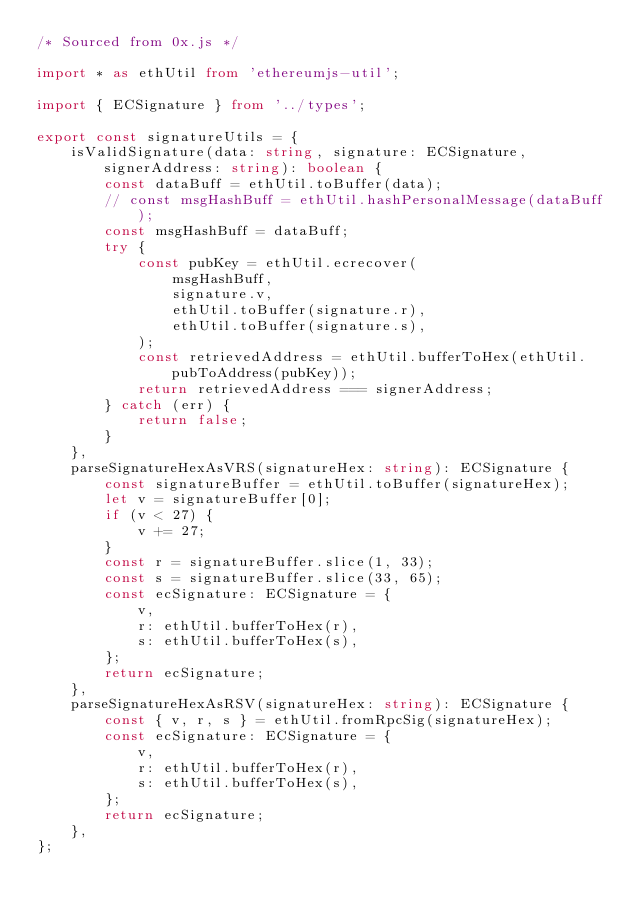<code> <loc_0><loc_0><loc_500><loc_500><_TypeScript_>/* Sourced from 0x.js */

import * as ethUtil from 'ethereumjs-util';

import { ECSignature } from '../types';

export const signatureUtils = {
    isValidSignature(data: string, signature: ECSignature, signerAddress: string): boolean {
        const dataBuff = ethUtil.toBuffer(data);
        // const msgHashBuff = ethUtil.hashPersonalMessage(dataBuff);
        const msgHashBuff = dataBuff;
        try {
            const pubKey = ethUtil.ecrecover(
                msgHashBuff,
                signature.v,
                ethUtil.toBuffer(signature.r),
                ethUtil.toBuffer(signature.s),
            );
            const retrievedAddress = ethUtil.bufferToHex(ethUtil.pubToAddress(pubKey));
            return retrievedAddress === signerAddress;
        } catch (err) {
            return false;
        }
    },
    parseSignatureHexAsVRS(signatureHex: string): ECSignature {
        const signatureBuffer = ethUtil.toBuffer(signatureHex);
        let v = signatureBuffer[0];
        if (v < 27) {
            v += 27;
        }
        const r = signatureBuffer.slice(1, 33);
        const s = signatureBuffer.slice(33, 65);
        const ecSignature: ECSignature = {
            v,
            r: ethUtil.bufferToHex(r),
            s: ethUtil.bufferToHex(s),
        };
        return ecSignature;
    },
    parseSignatureHexAsRSV(signatureHex: string): ECSignature {
        const { v, r, s } = ethUtil.fromRpcSig(signatureHex);
        const ecSignature: ECSignature = {
            v,
            r: ethUtil.bufferToHex(r),
            s: ethUtil.bufferToHex(s),
        };
        return ecSignature;
    },
};
</code> 